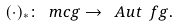Convert formula to latex. <formula><loc_0><loc_0><loc_500><loc_500>( \cdot ) _ { * } \colon \ m c g \to \ A u t { \ f g } .</formula> 